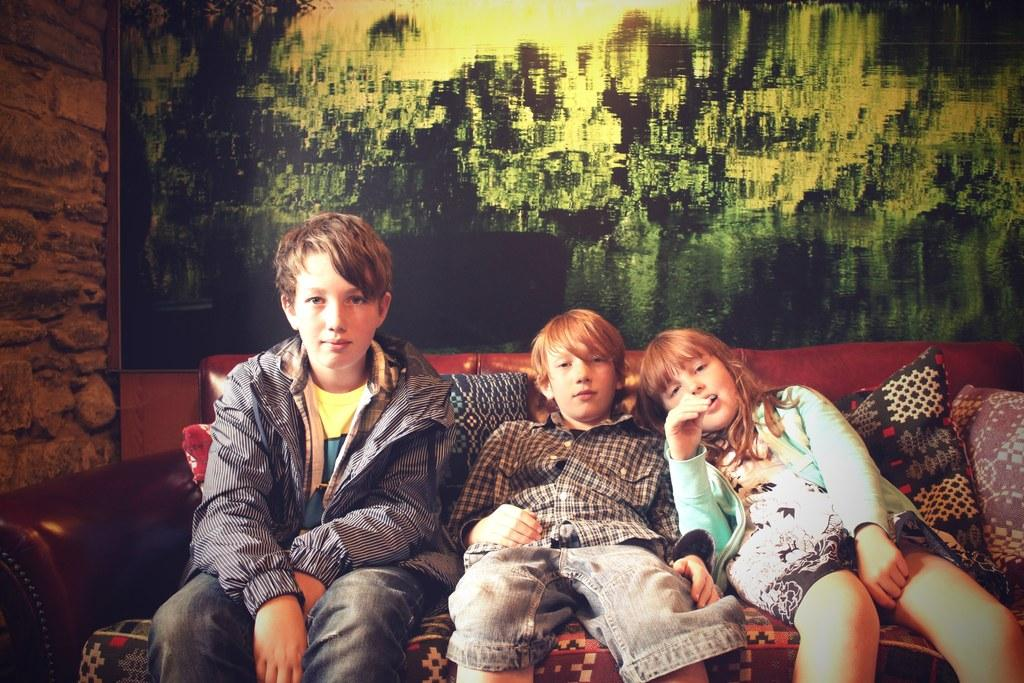How many kids are in the image? There are three kids in the image. What are the kids doing in the image? The kids are sitting on a sofa. What can be seen in the background of the image? There is a picture visible in the background. What type of amusement can be seen in the image? There is no amusement present in the image; it features three kids sitting on a sofa. Can you see a goat in the image? There is no goat present in the image. 